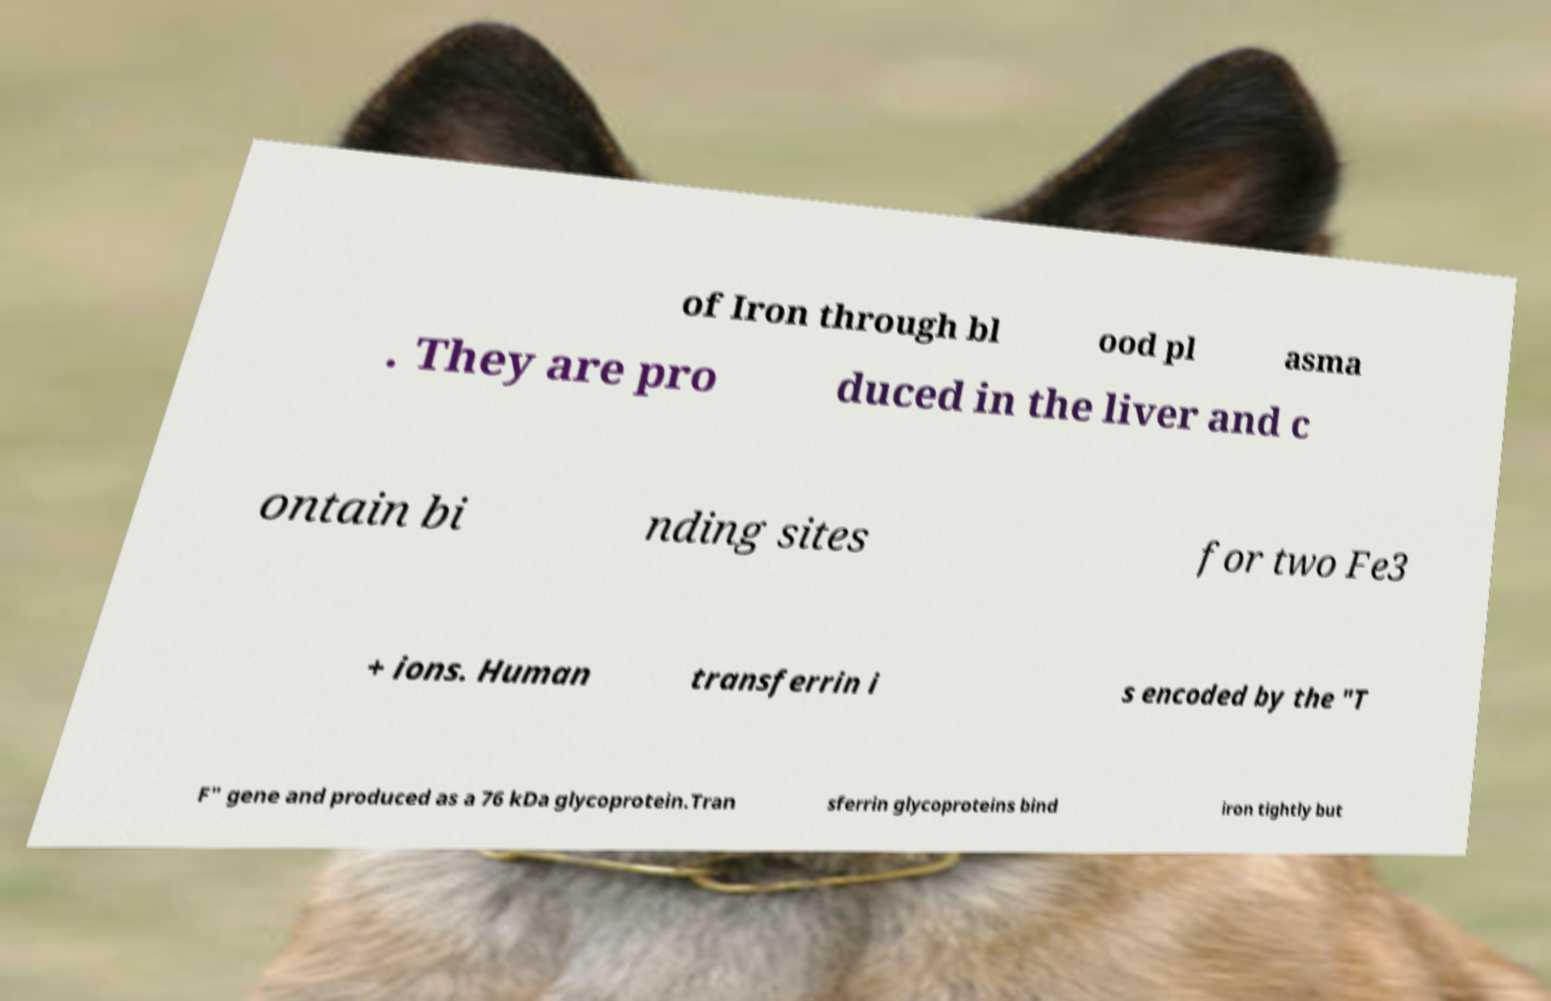Can you accurately transcribe the text from the provided image for me? of Iron through bl ood pl asma . They are pro duced in the liver and c ontain bi nding sites for two Fe3 + ions. Human transferrin i s encoded by the "T F" gene and produced as a 76 kDa glycoprotein.Tran sferrin glycoproteins bind iron tightly but 